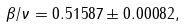<formula> <loc_0><loc_0><loc_500><loc_500>\beta / \nu = 0 . 5 1 5 8 7 \pm 0 . 0 0 0 8 2 ,</formula> 